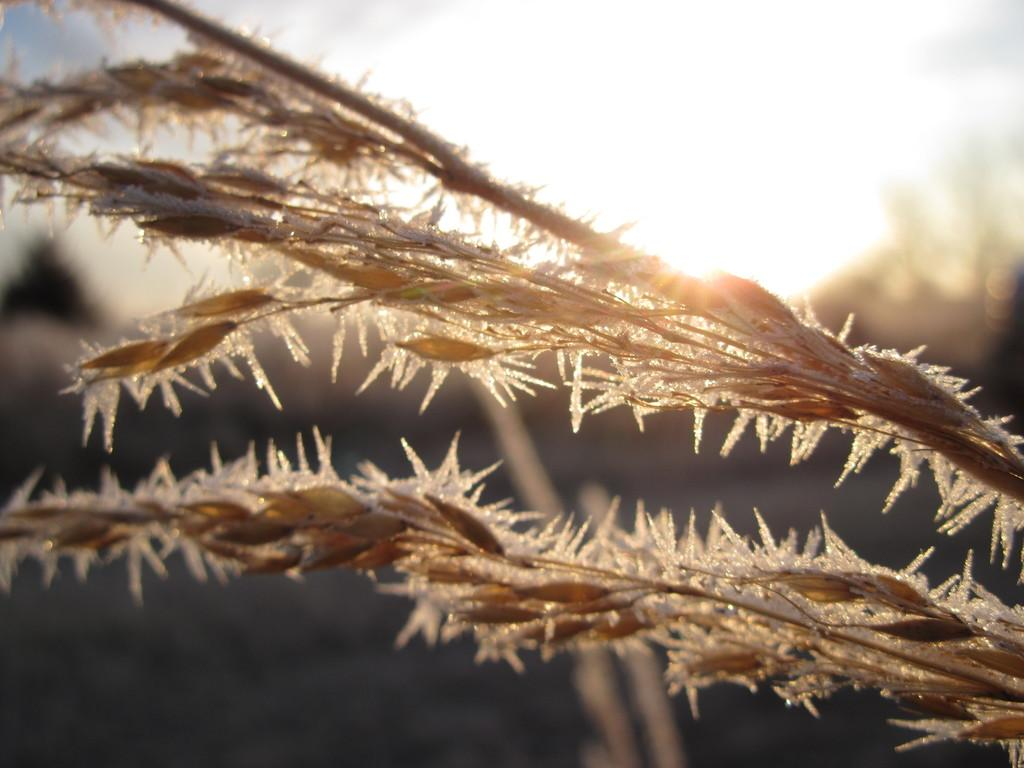What type of plant is present in the image? There is wheatgrass in the image. Can you describe the background of the image? The background of the image is blurred. What else can be seen in the background besides the blurred area? Objects are visible in the background. What is visible in the sky in the image? The sun is observable in the sky. What type of pickle is being tested in the image? There is no pickle present in the image, and no testing is being conducted. 